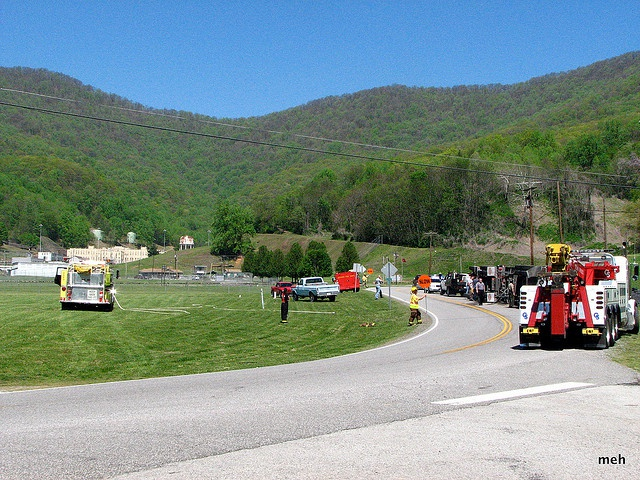Describe the objects in this image and their specific colors. I can see truck in gray, black, white, brown, and maroon tones, truck in gray, black, white, and darkgray tones, truck in gray, black, white, and darkgray tones, truck in gray, black, darkgray, and white tones, and people in gray, lightgray, black, khaki, and olive tones in this image. 